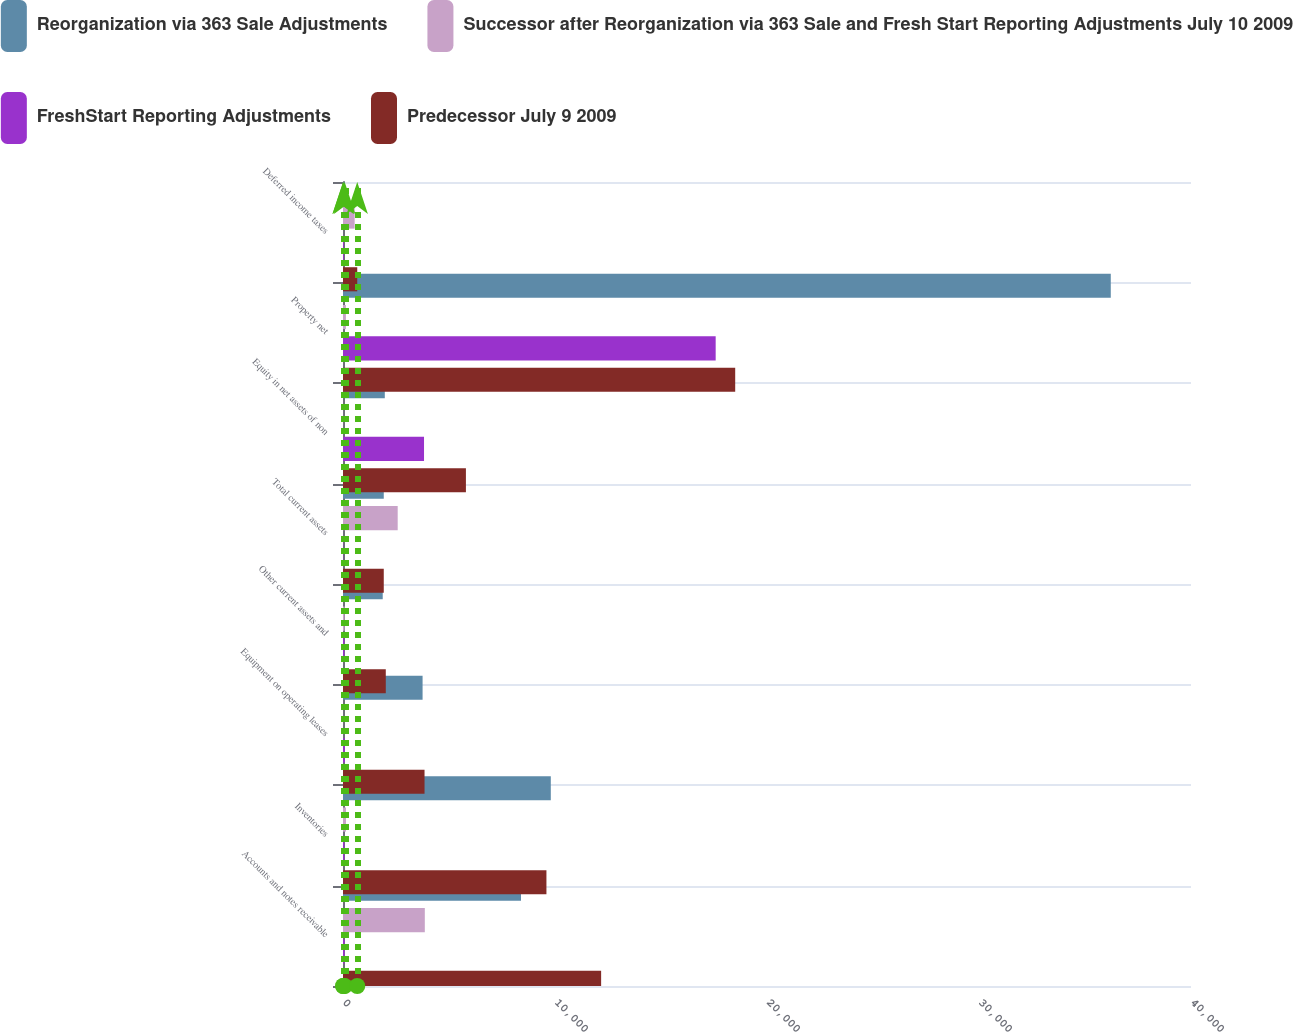Convert chart. <chart><loc_0><loc_0><loc_500><loc_500><stacked_bar_chart><ecel><fcel>Accounts and notes receivable<fcel>Inventories<fcel>Equipment on operating leases<fcel>Other current assets and<fcel>Total current assets<fcel>Equity in net assets of non<fcel>Property net<fcel>Deferred income taxes<nl><fcel>Reorganization via 363 Sale Adjustments<fcel>8396<fcel>9802<fcel>3754<fcel>1874<fcel>1923<fcel>1972<fcel>36216<fcel>79<nl><fcel>Successor after Reorganization via 363 Sale and Fresh Start Reporting Adjustments July 10 2009<fcel>3859<fcel>140<fcel>2<fcel>75<fcel>2580<fcel>4<fcel>137<fcel>550<nl><fcel>FreshStart Reporting Adjustments<fcel>79<fcel>66<fcel>90<fcel>69<fcel>14<fcel>3822<fcel>17579<fcel>43<nl><fcel>Predecessor July 9 2009<fcel>12176<fcel>9596<fcel>3846<fcel>2018<fcel>1923<fcel>5798<fcel>18500<fcel>672<nl></chart> 